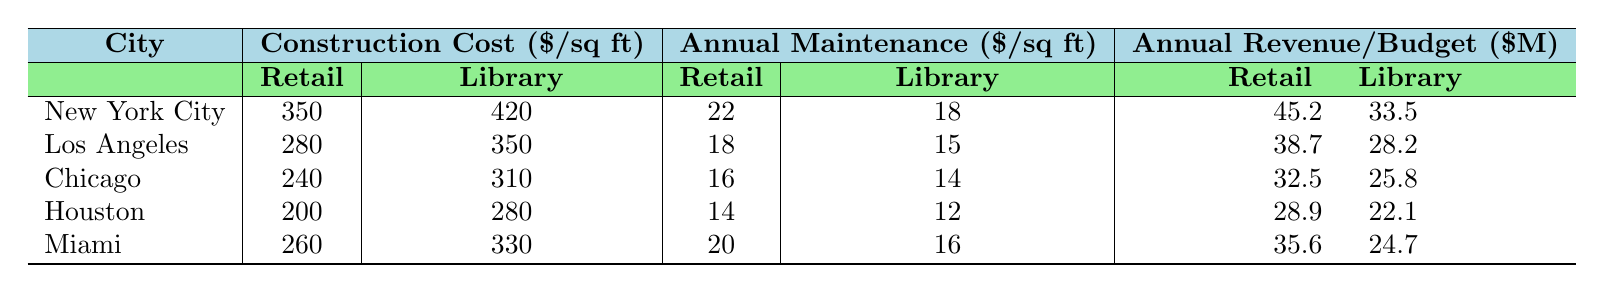What's the construction cost per square foot for retail spaces in Los Angeles? According to the table, the construction cost per square foot for retail spaces in Los Angeles is listed directly as 280.
Answer: 280 What is the total annual revenue for retail spaces in New York City? The table shows that the total annual revenue for retail spaces in New York City is listed as 45.2 million dollars.
Answer: 45.2 million Which city has the highest annual maintenance cost per square foot for public libraries? By comparing the annual maintenance costs for public libraries, New York City has the highest value at 18 dollars per square foot.
Answer: New York City What is the difference in construction costs per square foot between retail spaces and public libraries in Houston? In Houston, the construction cost for retail spaces is 200 and for public libraries is 280. The difference is calculated as 280 - 200 = 80.
Answer: 80 What is the average construction cost per square foot for retail spaces across all cities? The construction costs for retail spaces are 350, 280, 240, 200, and 260. Adding them gives 350 + 280 + 240 + 200 + 260 = 1330. Dividing by the number of cities (5) gives an average of 1330 / 5 = 266.
Answer: 266 Is the annual budget for public libraries in Chicago greater than the total annual revenue for retail spaces in Chicago? The annual budget for public libraries in Chicago is 25.8 million dollars, while the total annual revenue for retail spaces is 32.5 million dollars. Since 25.8 is less than 32.5, the statement is false.
Answer: No Which city has a lower annual maintenance cost for public libraries than the retail spaces in the same city? By examining the table, Chicago has a public library maintenance cost of 14, which is lower than the retail maintenance cost of 16 in the same city.
Answer: Chicago What is the combined construction cost per square foot for retail spaces and public libraries in Miami? The construction cost for retail spaces in Miami is 260 and for public libraries is 330. Adding these values gives 260 + 330 = 590.
Answer: 590 In which city is the difference in total annual revenue and annual budget for retail spaces and public libraries the greatest? Calculating the differences for each city: New York City is 45.2 - 33.5 = 11.7, Los Angeles is 38.7 - 28.2 = 10.5, Chicago is 32.5 - 25.8 = 6.7, Houston is 28.9 - 22.1 = 6.8, and Miami is 35.6 - 24.7 = 10.9. The greatest difference is in New York City with 11.7 million.
Answer: New York City What is the ratio of annual maintenance costs for retail spaces to public libraries in Chicago? In Chicago, the annual maintenance cost for retail spaces is 16 and for public libraries is 14. The ratio is calculated as 16 / 14, which simplifies to approximately 1.14.
Answer: 1.14 